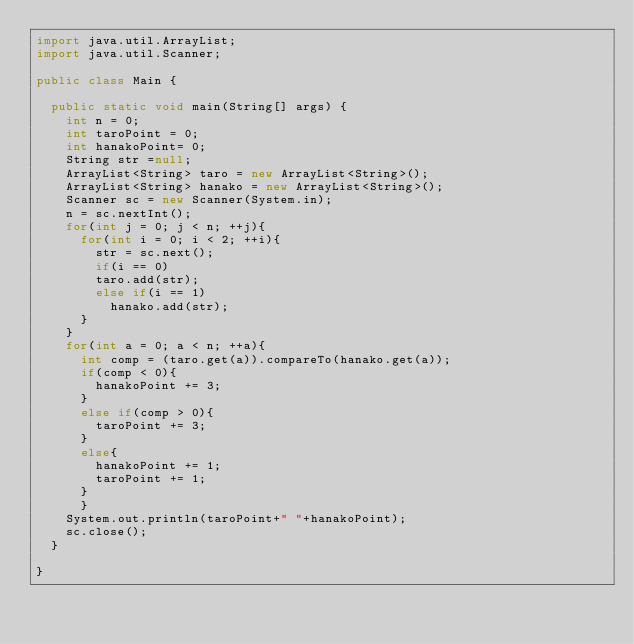Convert code to text. <code><loc_0><loc_0><loc_500><loc_500><_Java_>import java.util.ArrayList;
import java.util.Scanner;

public class Main {

	public static void main(String[] args) {
		int n = 0;
		int taroPoint = 0;
		int hanakoPoint= 0;
		String str =null;
		ArrayList<String> taro = new ArrayList<String>();
		ArrayList<String> hanako = new ArrayList<String>();
		Scanner sc = new Scanner(System.in);
		n = sc.nextInt();
		for(int j = 0; j < n; ++j){
			for(int i = 0; i < 2; ++i){
				str = sc.next();
				if(i == 0)
				taro.add(str);
				else if(i == 1)
					hanako.add(str);
			}
		}
		for(int a = 0; a < n; ++a){
			int comp = (taro.get(a)).compareTo(hanako.get(a));
			if(comp < 0){
				hanakoPoint += 3;
			}
			else if(comp > 0){
				taroPoint += 3;
			}
			else{
				hanakoPoint += 1;
				taroPoint += 1;
			}
			}
		System.out.println(taroPoint+" "+hanakoPoint);
		sc.close();
	}

}</code> 